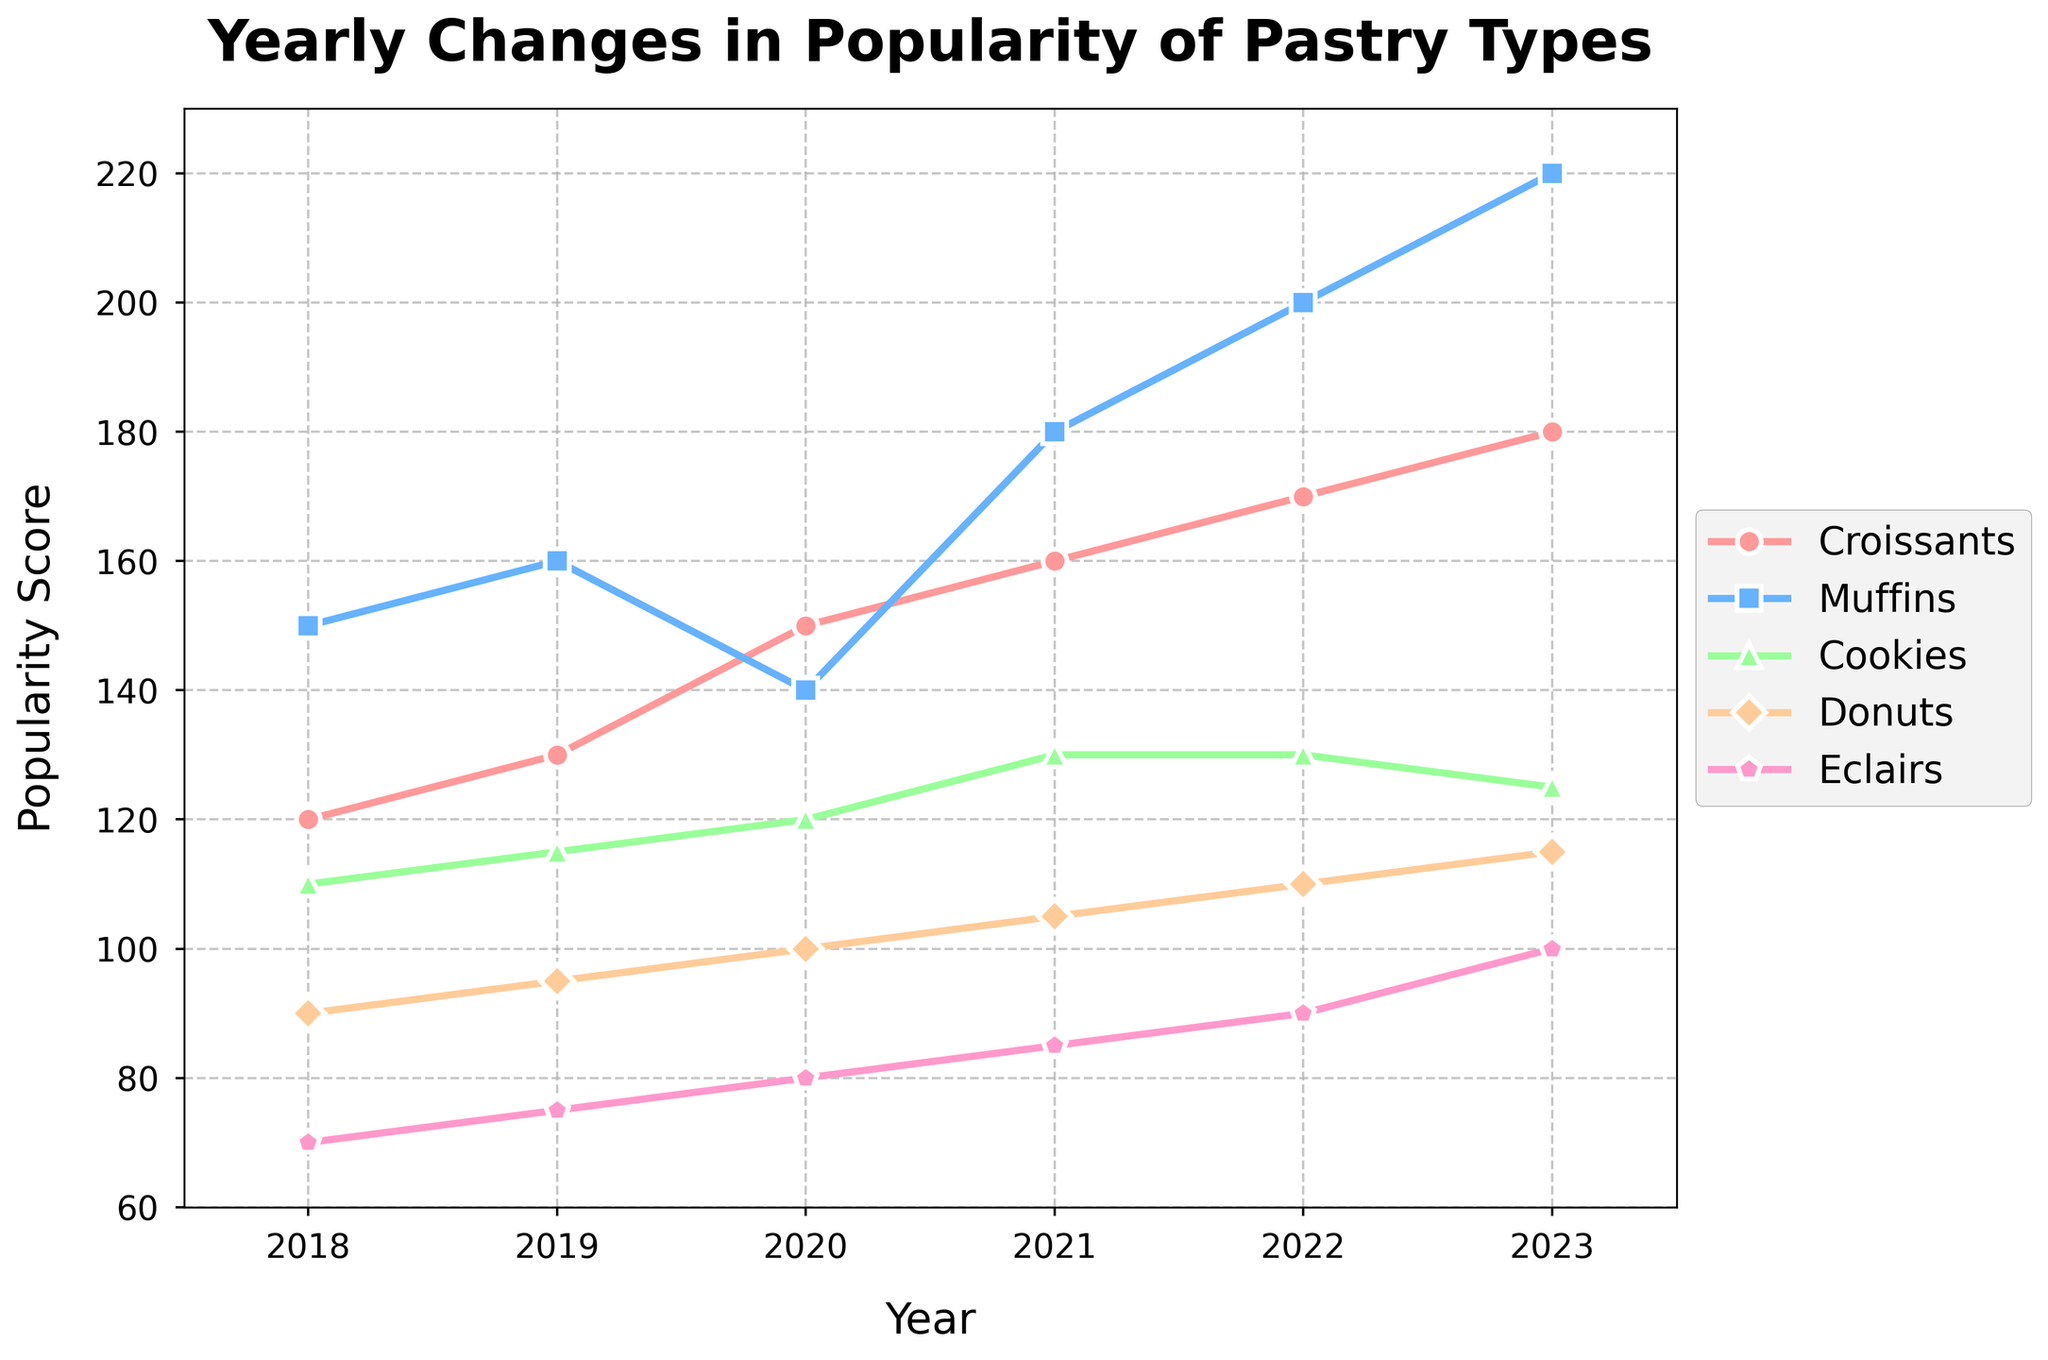What's the title of the figure? The title of the figure is usually located at the top of the chart. In this case, it is "Yearly Changes in Popularity of Pastry Types" as per the code provided.
Answer: Yearly Changes in Popularity of Pastry Types How many years of data are displayed in the figure? There are data points for each year between 2018 and 2023, inclusive. Counting these, we get six years of data.
Answer: 6 Which pastry type was the most popular in 2023? By looking at the popularity scores for 2023, the highest value among the pastry types is for Muffins.
Answer: Muffins Is there any pastry type that showed a decrease in popularity from 2022 to 2023? Comparing the popularity scores from 2022 to 2023, Cookies decreased from 130 to 125.
Answer: Cookies Which pastry type saw the highest increase in popularity from 2022 to 2023? Subtracting the 2022 popularity score from the 2023 score for each pastry type, Muffins had the highest increase (220 - 200 = 20).
Answer: Muffins What is the average popularity score of Croissants over the six years? The popularity scores for Croissants are 120, 130, 150, 160, 170, and 180. The average is calculated as (120 + 130 + 150 + 160 + 170 + 180) / 6.
Answer: 151.67 Did any pastry types have the same popularity score in a given year? Checking the scores year by year, the popularity scores for Cookies in 2021 and 2022 are both 130.
Answer: Yes Which pastry type had the least popularity in 2018? Comparing the scores from 2018, Eclairs had the lowest score of 70.
Answer: Eclairs Which years did Cookies show the most consistent popularity? From 2020 to 2022, Cookies' popularity scores were close to each other (120, 130, 130).
Answer: 2020-2022 How did the popularity of Donuts change from 2020 to 2021? The popularity score for Donuts increased from 100 in 2020 to 105 in 2021, a difference of 5.
Answer: Increased by 5 